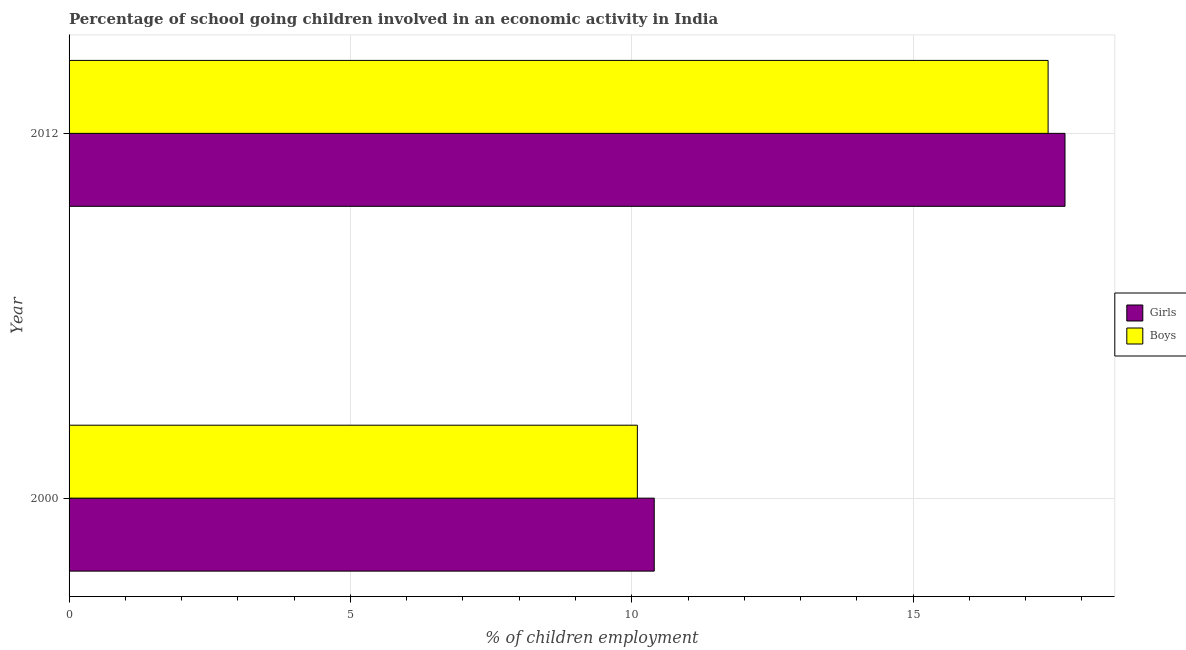How many bars are there on the 2nd tick from the top?
Provide a succinct answer. 2. What is the label of the 2nd group of bars from the top?
Give a very brief answer. 2000. In how many cases, is the number of bars for a given year not equal to the number of legend labels?
Offer a very short reply. 0. What is the total percentage of school going boys in the graph?
Keep it short and to the point. 27.5. What is the average percentage of school going boys per year?
Your answer should be very brief. 13.75. What is the ratio of the percentage of school going girls in 2000 to that in 2012?
Provide a succinct answer. 0.59. What does the 1st bar from the top in 2012 represents?
Provide a succinct answer. Boys. What does the 1st bar from the bottom in 2012 represents?
Keep it short and to the point. Girls. How many bars are there?
Ensure brevity in your answer.  4. Are all the bars in the graph horizontal?
Your answer should be compact. Yes. What is the difference between two consecutive major ticks on the X-axis?
Offer a terse response. 5. Does the graph contain any zero values?
Make the answer very short. No. Does the graph contain grids?
Make the answer very short. Yes. How many legend labels are there?
Offer a terse response. 2. How are the legend labels stacked?
Your answer should be compact. Vertical. What is the title of the graph?
Your answer should be compact. Percentage of school going children involved in an economic activity in India. Does "Diesel" appear as one of the legend labels in the graph?
Keep it short and to the point. No. What is the label or title of the X-axis?
Your answer should be compact. % of children employment. What is the label or title of the Y-axis?
Provide a short and direct response. Year. What is the % of children employment of Girls in 2000?
Offer a very short reply. 10.4. What is the % of children employment in Boys in 2012?
Provide a short and direct response. 17.4. Across all years, what is the minimum % of children employment of Boys?
Keep it short and to the point. 10.1. What is the total % of children employment of Girls in the graph?
Give a very brief answer. 28.1. What is the total % of children employment of Boys in the graph?
Keep it short and to the point. 27.5. What is the difference between the % of children employment in Girls in 2000 and that in 2012?
Make the answer very short. -7.3. What is the difference between the % of children employment of Boys in 2000 and that in 2012?
Your answer should be compact. -7.3. What is the difference between the % of children employment in Girls in 2000 and the % of children employment in Boys in 2012?
Make the answer very short. -7. What is the average % of children employment in Girls per year?
Make the answer very short. 14.05. What is the average % of children employment in Boys per year?
Provide a short and direct response. 13.75. What is the ratio of the % of children employment in Girls in 2000 to that in 2012?
Keep it short and to the point. 0.59. What is the ratio of the % of children employment in Boys in 2000 to that in 2012?
Make the answer very short. 0.58. What is the difference between the highest and the second highest % of children employment of Boys?
Give a very brief answer. 7.3. What is the difference between the highest and the lowest % of children employment in Girls?
Provide a short and direct response. 7.3. What is the difference between the highest and the lowest % of children employment in Boys?
Your answer should be very brief. 7.3. 